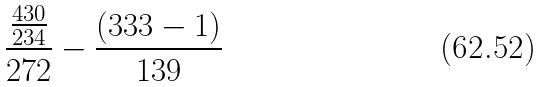<formula> <loc_0><loc_0><loc_500><loc_500>\frac { \frac { 4 3 0 } { 2 3 4 } } { 2 7 2 } - \frac { ( 3 3 3 - 1 ) } { 1 3 9 }</formula> 